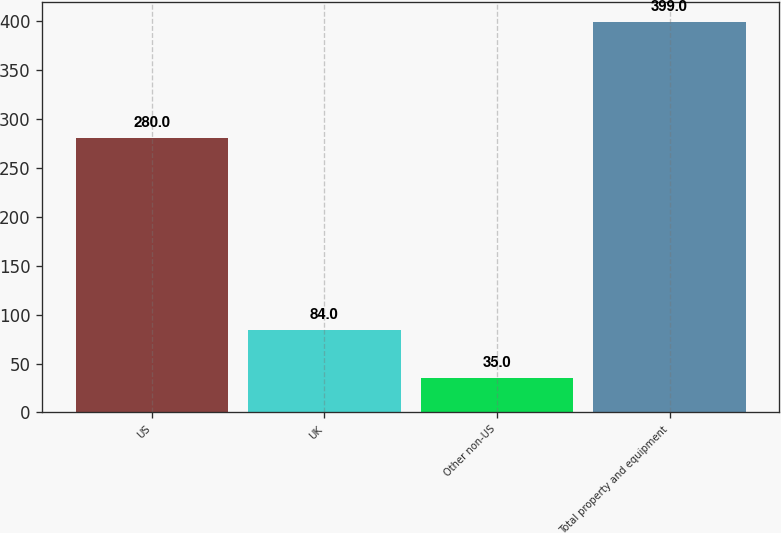<chart> <loc_0><loc_0><loc_500><loc_500><bar_chart><fcel>US<fcel>UK<fcel>Other non-US<fcel>Total property and equipment<nl><fcel>280<fcel>84<fcel>35<fcel>399<nl></chart> 